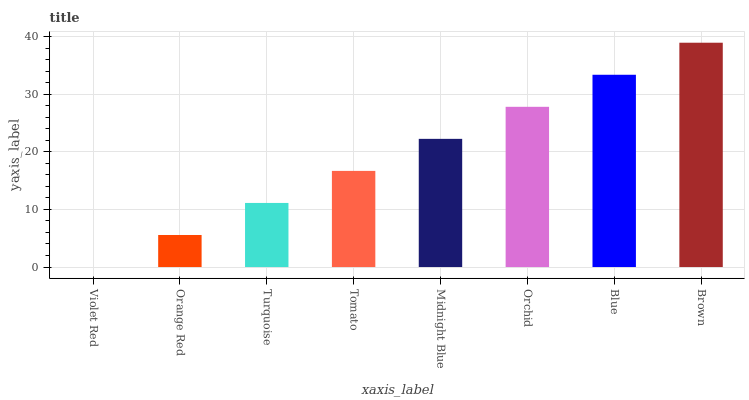Is Violet Red the minimum?
Answer yes or no. Yes. Is Brown the maximum?
Answer yes or no. Yes. Is Orange Red the minimum?
Answer yes or no. No. Is Orange Red the maximum?
Answer yes or no. No. Is Orange Red greater than Violet Red?
Answer yes or no. Yes. Is Violet Red less than Orange Red?
Answer yes or no. Yes. Is Violet Red greater than Orange Red?
Answer yes or no. No. Is Orange Red less than Violet Red?
Answer yes or no. No. Is Midnight Blue the high median?
Answer yes or no. Yes. Is Tomato the low median?
Answer yes or no. Yes. Is Violet Red the high median?
Answer yes or no. No. Is Midnight Blue the low median?
Answer yes or no. No. 